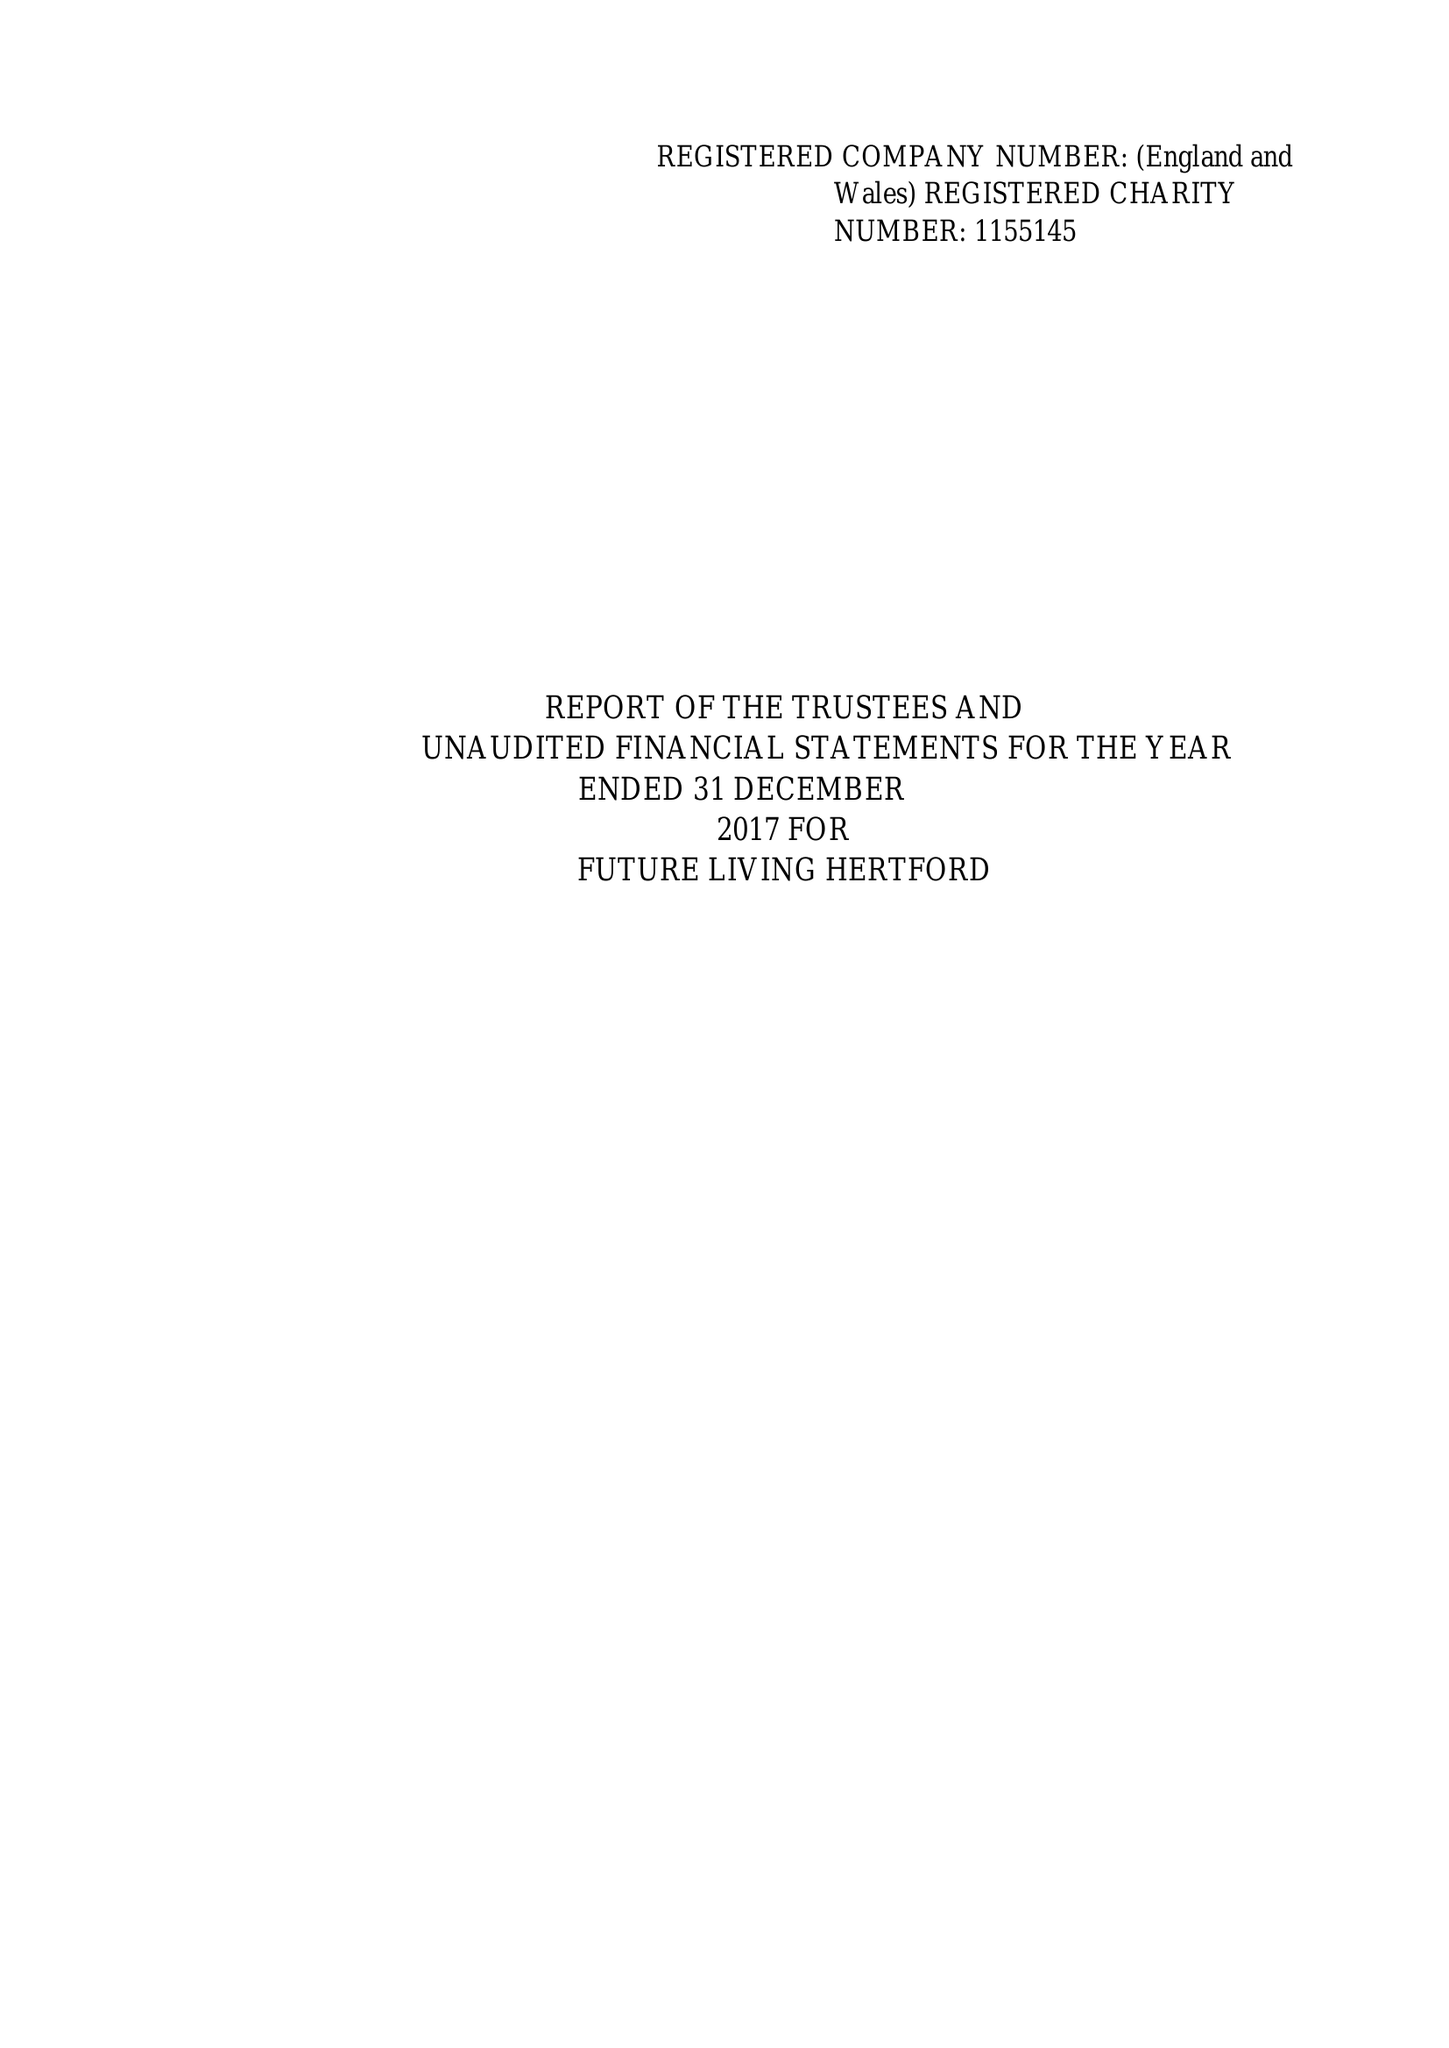What is the value for the spending_annually_in_british_pounds?
Answer the question using a single word or phrase. 120686.00 